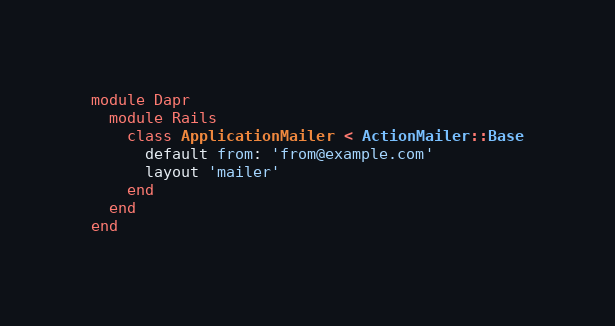Convert code to text. <code><loc_0><loc_0><loc_500><loc_500><_Ruby_>module Dapr
  module Rails
    class ApplicationMailer < ActionMailer::Base
      default from: 'from@example.com'
      layout 'mailer'
    end
  end
end
</code> 